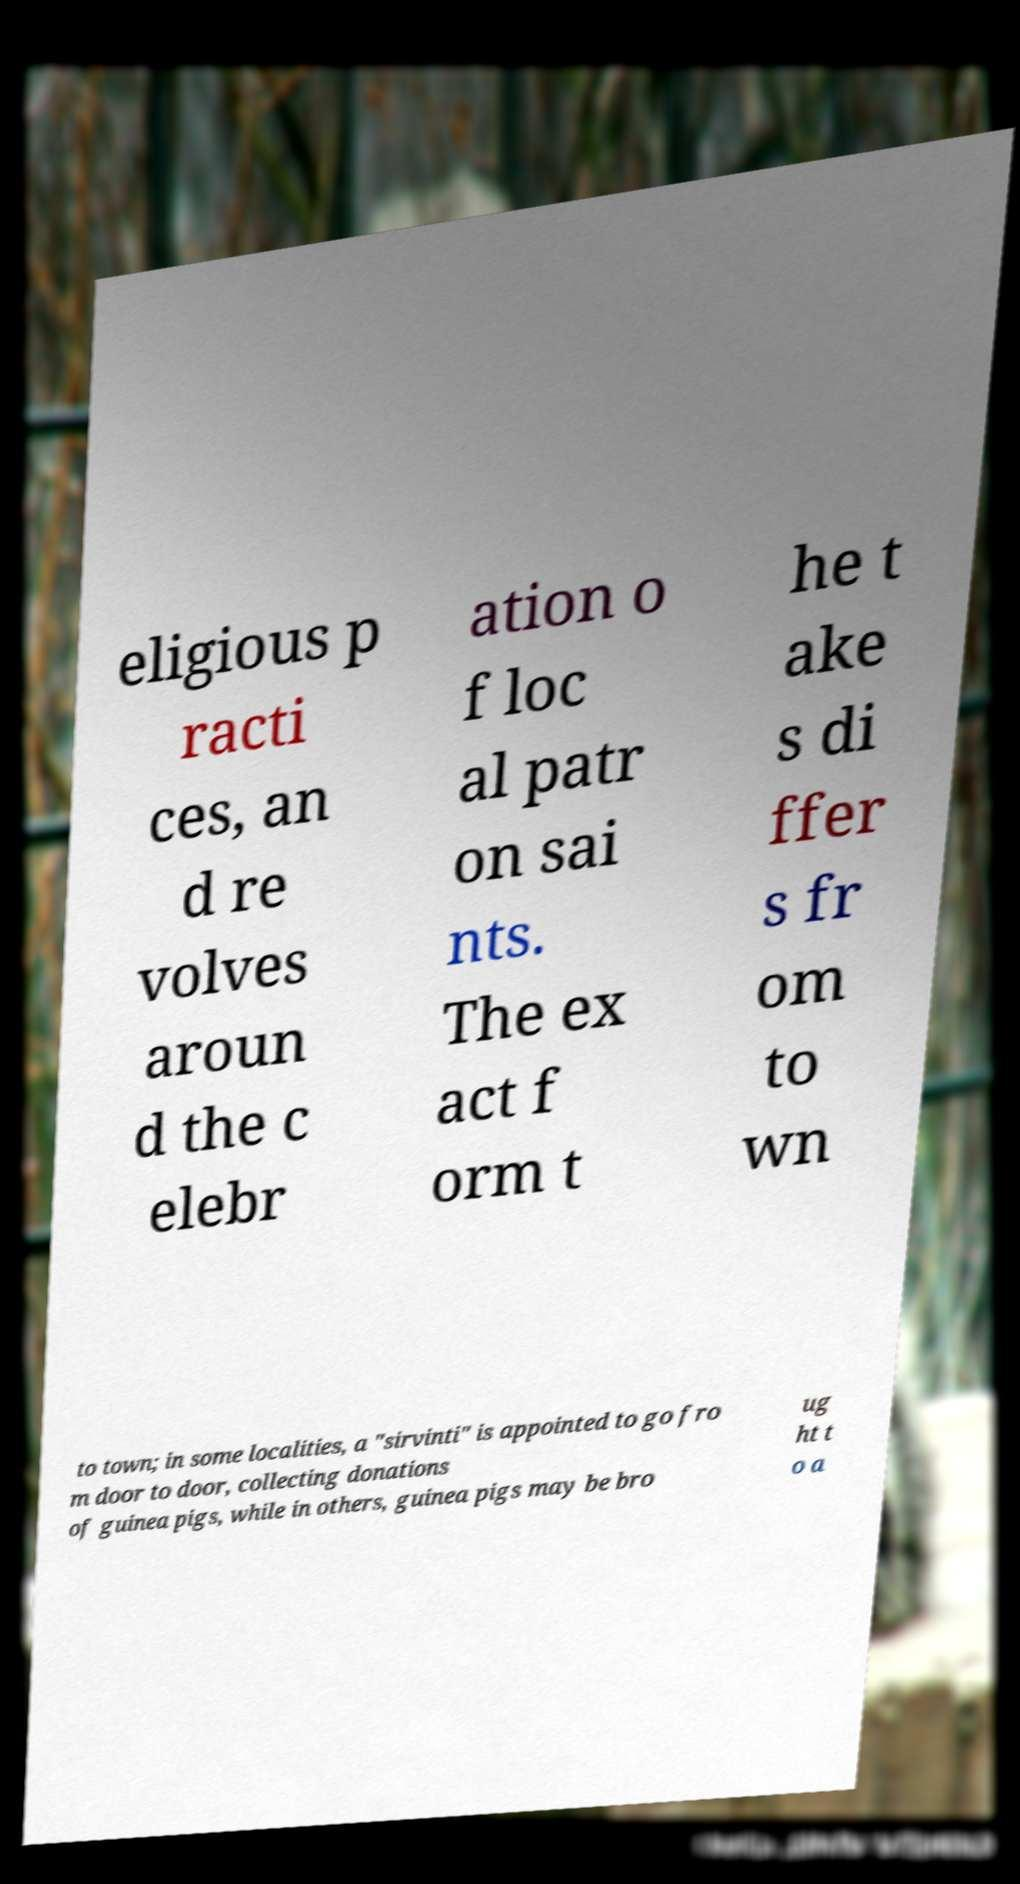Can you accurately transcribe the text from the provided image for me? eligious p racti ces, an d re volves aroun d the c elebr ation o f loc al patr on sai nts. The ex act f orm t he t ake s di ffer s fr om to wn to town; in some localities, a "sirvinti" is appointed to go fro m door to door, collecting donations of guinea pigs, while in others, guinea pigs may be bro ug ht t o a 